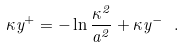<formula> <loc_0><loc_0><loc_500><loc_500>\kappa y ^ { + } = - \ln \frac { \kappa ^ { 2 } } { a ^ { 2 } } + \kappa y ^ { - } \ .</formula> 